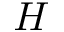Convert formula to latex. <formula><loc_0><loc_0><loc_500><loc_500>H</formula> 